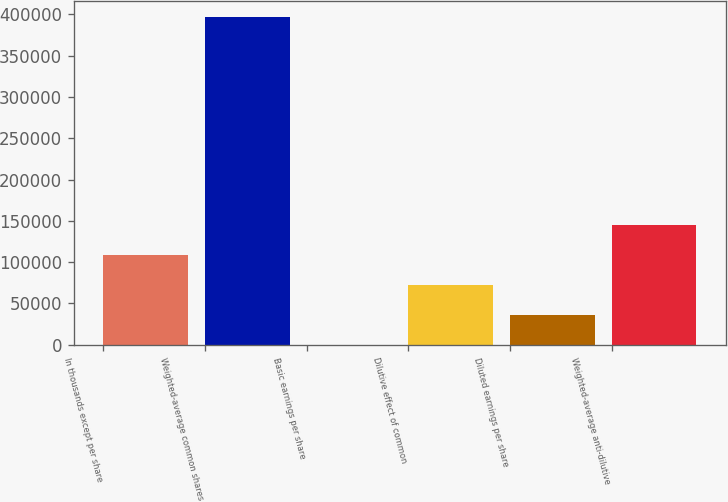Convert chart to OTSL. <chart><loc_0><loc_0><loc_500><loc_500><bar_chart><fcel>In thousands except per share<fcel>Weighted-average common shares<fcel>Basic earnings per share<fcel>Dilutive effect of common<fcel>Diluted earnings per share<fcel>Weighted-average anti-dilutive<nl><fcel>108297<fcel>396881<fcel>1.48<fcel>72198.2<fcel>36099.8<fcel>144395<nl></chart> 